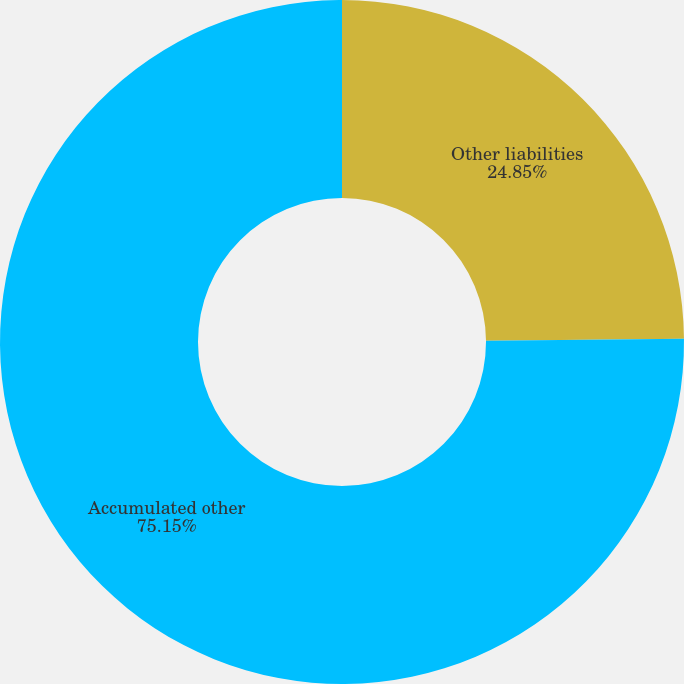Convert chart to OTSL. <chart><loc_0><loc_0><loc_500><loc_500><pie_chart><fcel>Other liabilities<fcel>Accumulated other<nl><fcel>24.85%<fcel>75.15%<nl></chart> 